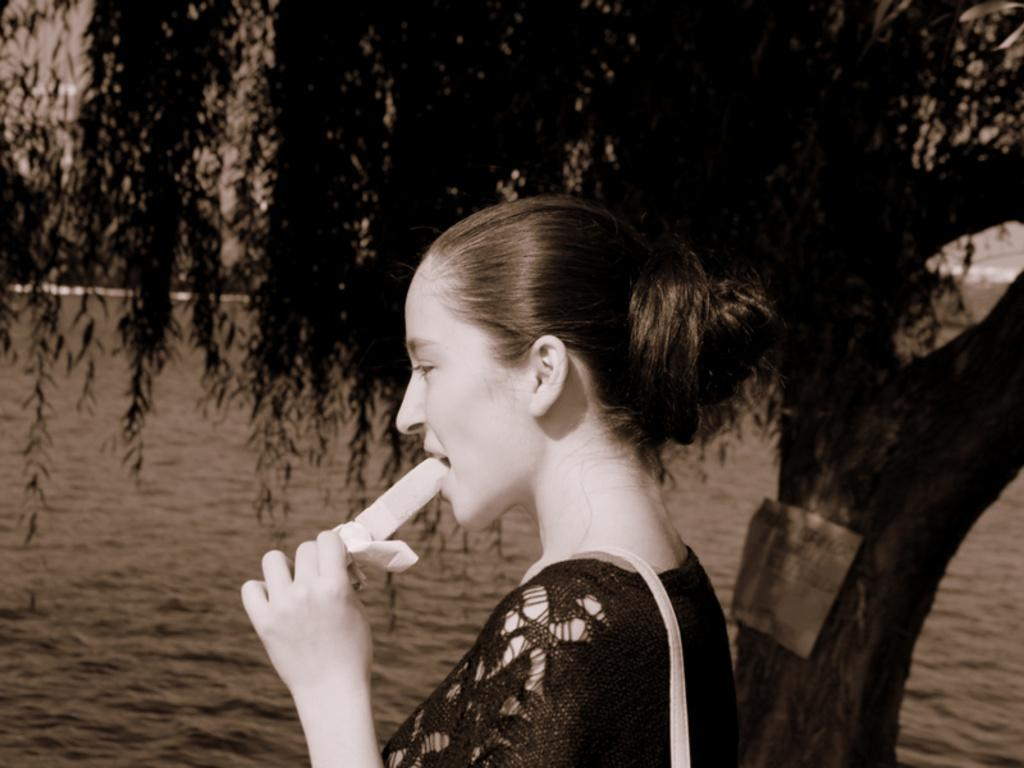Who is the main subject in the image? There is a woman in the image. What is the woman doing in the image? The woman is eating an ice cream. What else can be seen on the woman in the image? The woman is carrying a bag on her shoulder. What can be seen in the background of the image? There is water, a small board on a tree, and the sky visible in the background of the image. What type of cake is the woman holding in the image? There is no cake present in the image; the woman is eating an ice cream. What kind of wax is being used to create the oatmeal in the image? There is no wax or oatmeal present in the image. 